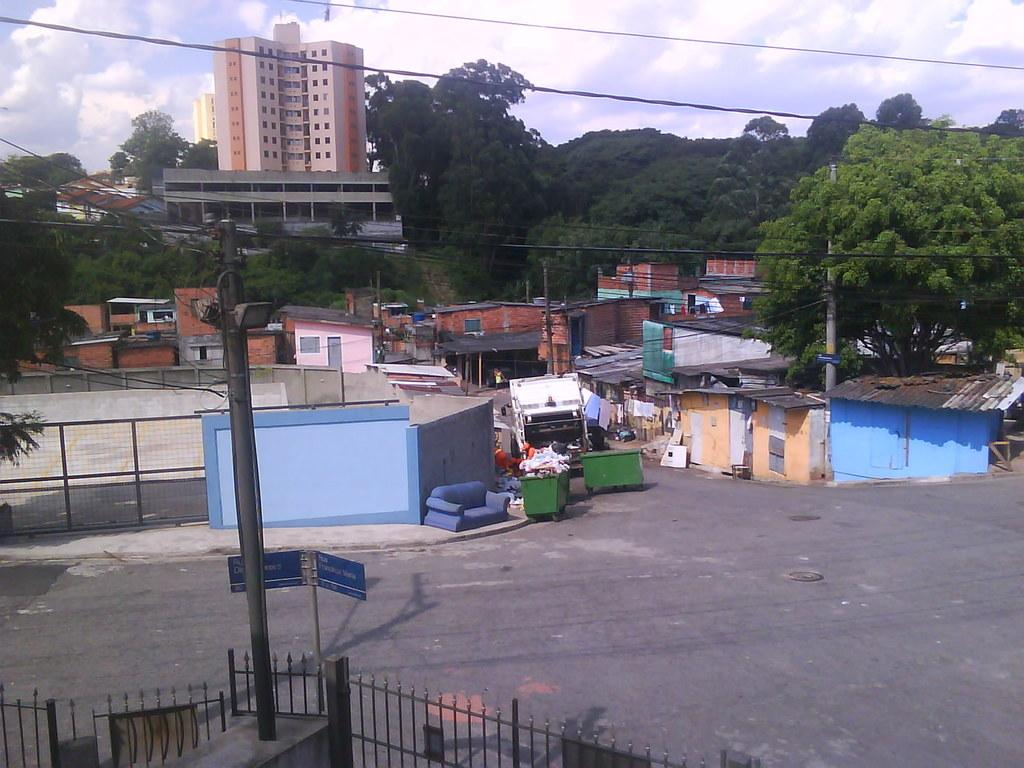What types of structures can be seen in the image? There are buildings and houses in the image. What natural elements are present in the image? There are trees in the image. What man-made objects can be seen in the image? There are poles, cables, a signboard, fences, trash bins, and a vehicle in the image. What is visible in the sky in the image? There are clouds in the sky in the image. What type of dinner is being served on the patch in the image? There is no dinner or patch present in the image. What is the afterthought of the person who designed the signboard in the image? We cannot determine the afterthought of the person who designed the signboard from the image alone. 